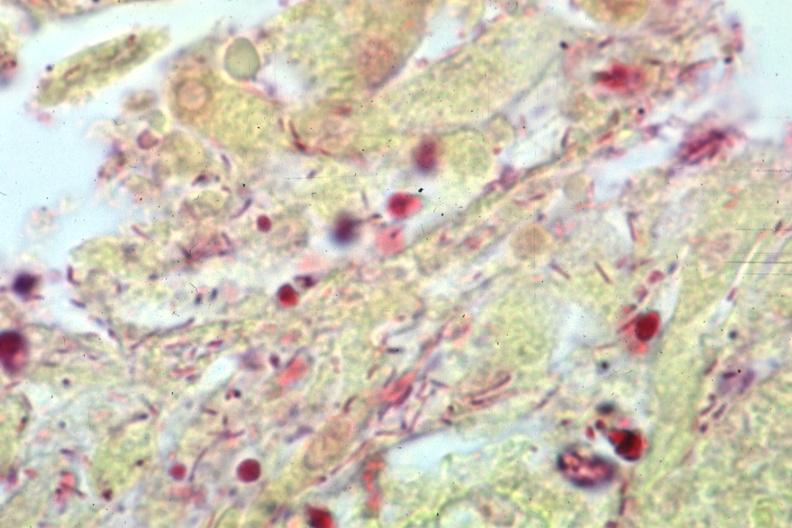what stain gram negative bacteria?
Answer the question using a single word or phrase. Gram 